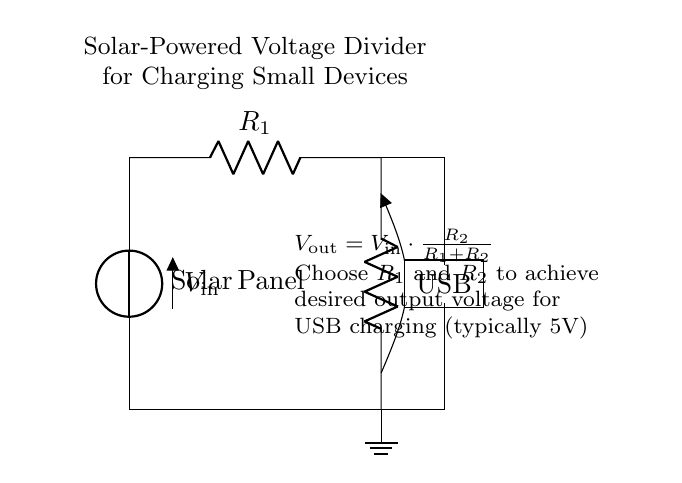What is the input voltage of the circuit? The input voltage, as indicated by the label on the solar panel, is labeled as Vin above it. Typically, solar panels can have varying voltage outputs; however, it is common to see values like 6V or more depending on the design.
Answer: Vin What are the components present in this circuit? The circuit diagram indicates two resistors (R1 and R2), a solar panel, and a USB output symbol. The resistors are crucial for creating the voltage divider, and the USB symbol represents where the output voltage will be utilized to charge devices.
Answer: Solar Panel, R1, R2, USB What is the role of resistor R2 in the voltage divider? Resistor R2 is significant because it plays a key role in determining the output voltage Vout. The output voltage is calculated based on the ratio of R2 to the total resistance (R1 + R2). A larger R2 relative to R1 will yield a higher output voltage.
Answer: To set output voltage How is the output voltage calculated in this circuit? The output voltage, as described in the circuit explanation, is calculated using the formula Vout = Vin * (R2 / (R1 + R2)). This formula illustrates how the division of input voltage occurs across the two resistors according to their resistance values.
Answer: Vout = Vin * (R2 / (R1 + R2)) What should R1 and R2 be chosen for? R1 and R2 should be selected to achieve the desired output voltage necessary for USB charging, which is typically 5 volts. The choice of these resistors directly impacts the voltage output that will be suitable for small electronic devices.
Answer: To achieve 5V output 